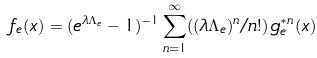<formula> <loc_0><loc_0><loc_500><loc_500>f _ { e } ( x ) = ( e ^ { \lambda \Lambda _ { e } } - 1 ) ^ { - 1 } \sum _ { n = 1 } ^ { \infty } ( ( \lambda \Lambda _ { e } ) ^ { n } / n ! ) \, g _ { e } ^ { \ast n } ( x )</formula> 